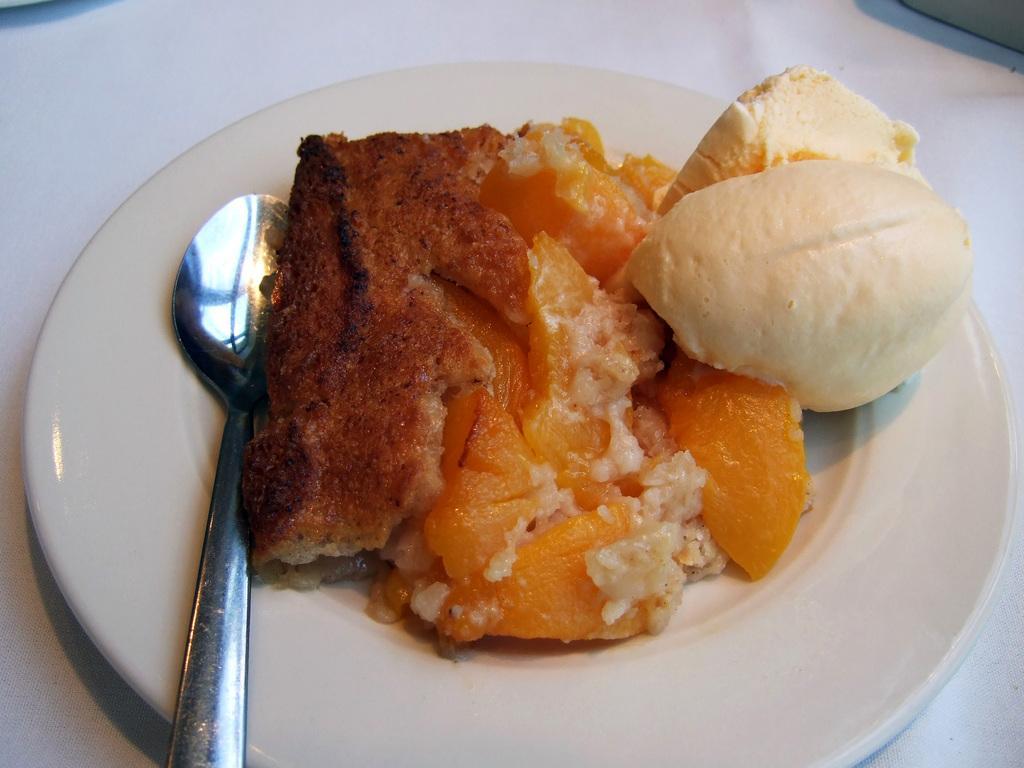Can you describe this image briefly? On a white plate there are food items and a spoon. 